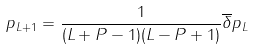<formula> <loc_0><loc_0><loc_500><loc_500>p _ { L + 1 } = \frac { 1 } { ( L + P - 1 ) ( L - P + 1 ) } \overline { \delta } p _ { L }</formula> 